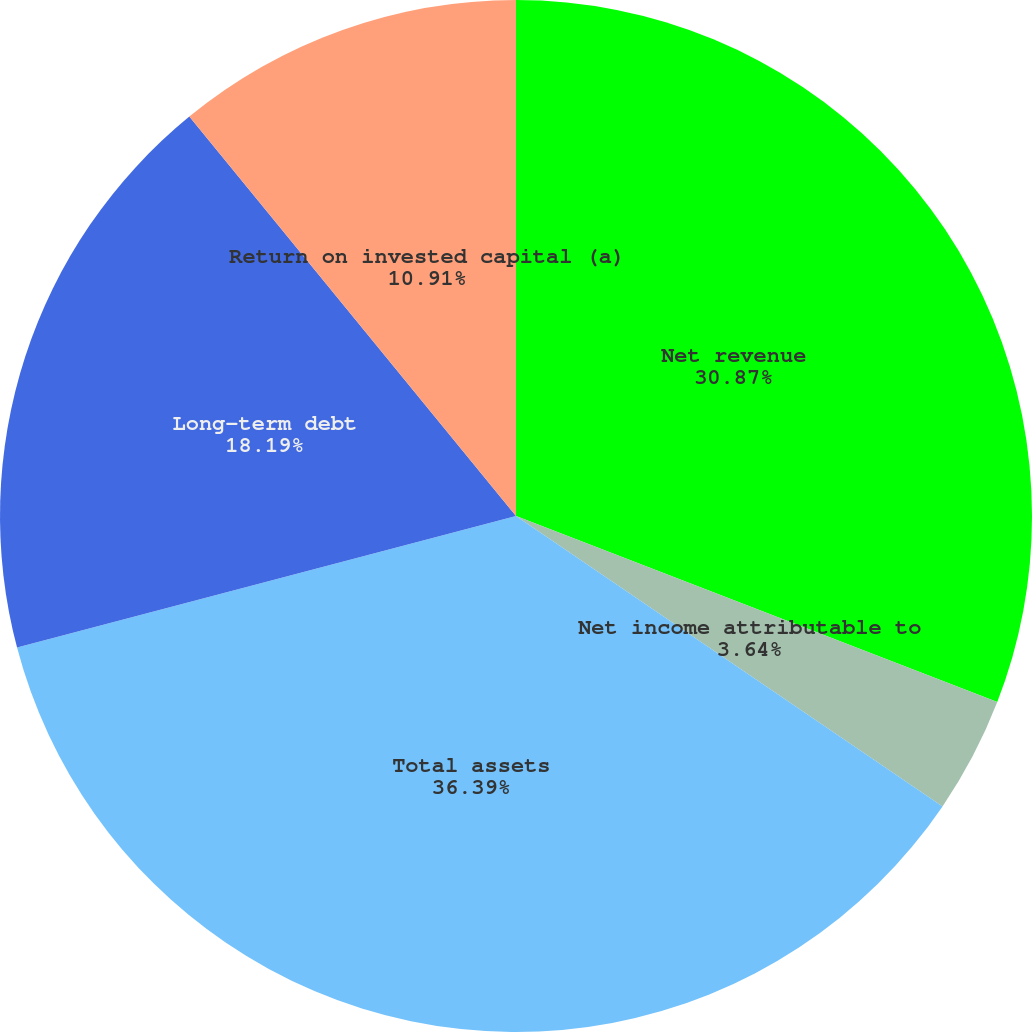<chart> <loc_0><loc_0><loc_500><loc_500><pie_chart><fcel>Net revenue<fcel>Net income attributable to<fcel>Cash dividends declared per<fcel>Total assets<fcel>Long-term debt<fcel>Return on invested capital (a)<nl><fcel>30.87%<fcel>3.64%<fcel>0.0%<fcel>36.38%<fcel>18.19%<fcel>10.91%<nl></chart> 